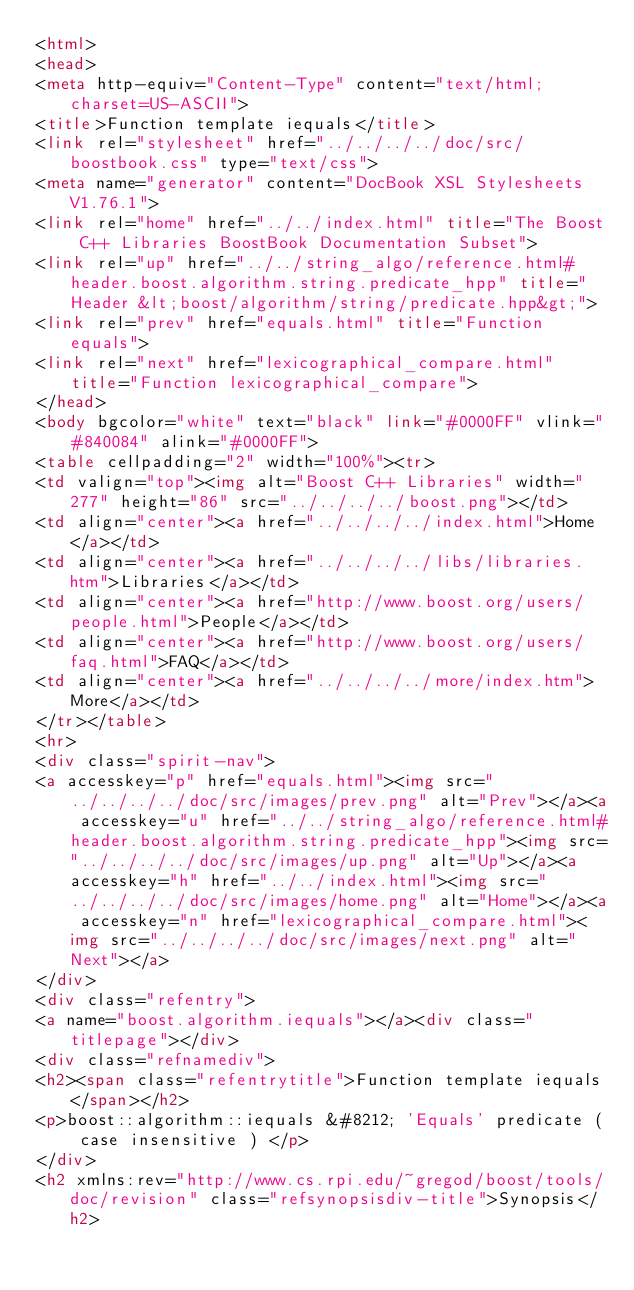Convert code to text. <code><loc_0><loc_0><loc_500><loc_500><_HTML_><html>
<head>
<meta http-equiv="Content-Type" content="text/html; charset=US-ASCII">
<title>Function template iequals</title>
<link rel="stylesheet" href="../../../../doc/src/boostbook.css" type="text/css">
<meta name="generator" content="DocBook XSL Stylesheets V1.76.1">
<link rel="home" href="../../index.html" title="The Boost C++ Libraries BoostBook Documentation Subset">
<link rel="up" href="../../string_algo/reference.html#header.boost.algorithm.string.predicate_hpp" title="Header &lt;boost/algorithm/string/predicate.hpp&gt;">
<link rel="prev" href="equals.html" title="Function equals">
<link rel="next" href="lexicographical_compare.html" title="Function lexicographical_compare">
</head>
<body bgcolor="white" text="black" link="#0000FF" vlink="#840084" alink="#0000FF">
<table cellpadding="2" width="100%"><tr>
<td valign="top"><img alt="Boost C++ Libraries" width="277" height="86" src="../../../../boost.png"></td>
<td align="center"><a href="../../../../index.html">Home</a></td>
<td align="center"><a href="../../../../libs/libraries.htm">Libraries</a></td>
<td align="center"><a href="http://www.boost.org/users/people.html">People</a></td>
<td align="center"><a href="http://www.boost.org/users/faq.html">FAQ</a></td>
<td align="center"><a href="../../../../more/index.htm">More</a></td>
</tr></table>
<hr>
<div class="spirit-nav">
<a accesskey="p" href="equals.html"><img src="../../../../doc/src/images/prev.png" alt="Prev"></a><a accesskey="u" href="../../string_algo/reference.html#header.boost.algorithm.string.predicate_hpp"><img src="../../../../doc/src/images/up.png" alt="Up"></a><a accesskey="h" href="../../index.html"><img src="../../../../doc/src/images/home.png" alt="Home"></a><a accesskey="n" href="lexicographical_compare.html"><img src="../../../../doc/src/images/next.png" alt="Next"></a>
</div>
<div class="refentry">
<a name="boost.algorithm.iequals"></a><div class="titlepage"></div>
<div class="refnamediv">
<h2><span class="refentrytitle">Function template iequals</span></h2>
<p>boost::algorithm::iequals &#8212; 'Equals' predicate ( case insensitive ) </p>
</div>
<h2 xmlns:rev="http://www.cs.rpi.edu/~gregod/boost/tools/doc/revision" class="refsynopsisdiv-title">Synopsis</h2></code> 